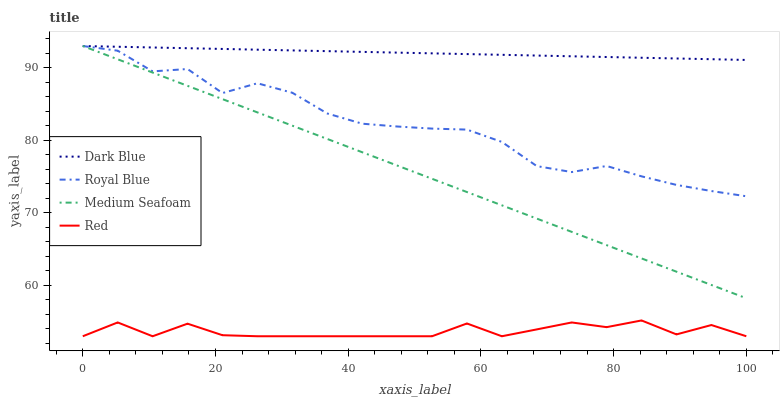Does Red have the minimum area under the curve?
Answer yes or no. Yes. Does Dark Blue have the maximum area under the curve?
Answer yes or no. Yes. Does Medium Seafoam have the minimum area under the curve?
Answer yes or no. No. Does Medium Seafoam have the maximum area under the curve?
Answer yes or no. No. Is Dark Blue the smoothest?
Answer yes or no. Yes. Is Red the roughest?
Answer yes or no. Yes. Is Medium Seafoam the smoothest?
Answer yes or no. No. Is Medium Seafoam the roughest?
Answer yes or no. No. Does Red have the lowest value?
Answer yes or no. Yes. Does Medium Seafoam have the lowest value?
Answer yes or no. No. Does Royal Blue have the highest value?
Answer yes or no. Yes. Does Red have the highest value?
Answer yes or no. No. Is Red less than Dark Blue?
Answer yes or no. Yes. Is Medium Seafoam greater than Red?
Answer yes or no. Yes. Does Dark Blue intersect Royal Blue?
Answer yes or no. Yes. Is Dark Blue less than Royal Blue?
Answer yes or no. No. Is Dark Blue greater than Royal Blue?
Answer yes or no. No. Does Red intersect Dark Blue?
Answer yes or no. No. 